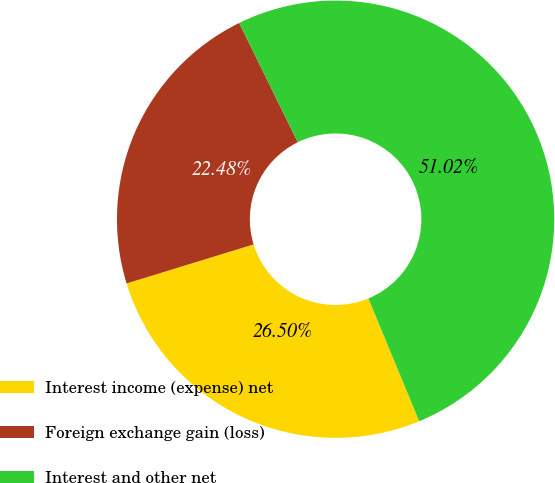Convert chart. <chart><loc_0><loc_0><loc_500><loc_500><pie_chart><fcel>Interest income (expense) net<fcel>Foreign exchange gain (loss)<fcel>Interest and other net<nl><fcel>26.5%<fcel>22.48%<fcel>51.02%<nl></chart> 